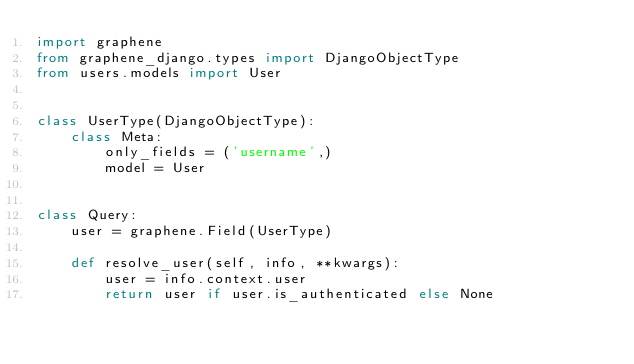<code> <loc_0><loc_0><loc_500><loc_500><_Python_>import graphene
from graphene_django.types import DjangoObjectType
from users.models import User


class UserType(DjangoObjectType):
    class Meta:
        only_fields = ('username',)
        model = User


class Query:
    user = graphene.Field(UserType)

    def resolve_user(self, info, **kwargs):
        user = info.context.user
        return user if user.is_authenticated else None
</code> 